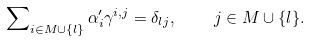Convert formula to latex. <formula><loc_0><loc_0><loc_500><loc_500>\sum \nolimits _ { i \in M \cup \{ l \} } \alpha ^ { \prime } _ { i } \gamma ^ { i , j } = \delta _ { l j } , \quad j \in M \cup \{ l \} .</formula> 